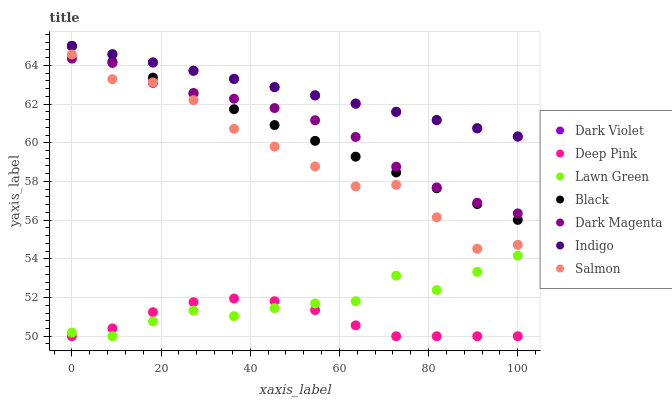Does Deep Pink have the minimum area under the curve?
Answer yes or no. Yes. Does Indigo have the maximum area under the curve?
Answer yes or no. Yes. Does Indigo have the minimum area under the curve?
Answer yes or no. No. Does Deep Pink have the maximum area under the curve?
Answer yes or no. No. Is Dark Violet the smoothest?
Answer yes or no. Yes. Is Lawn Green the roughest?
Answer yes or no. Yes. Is Deep Pink the smoothest?
Answer yes or no. No. Is Deep Pink the roughest?
Answer yes or no. No. Does Lawn Green have the lowest value?
Answer yes or no. Yes. Does Indigo have the lowest value?
Answer yes or no. No. Does Black have the highest value?
Answer yes or no. Yes. Does Deep Pink have the highest value?
Answer yes or no. No. Is Salmon less than Indigo?
Answer yes or no. Yes. Is Dark Violet greater than Lawn Green?
Answer yes or no. Yes. Does Black intersect Dark Violet?
Answer yes or no. Yes. Is Black less than Dark Violet?
Answer yes or no. No. Is Black greater than Dark Violet?
Answer yes or no. No. Does Salmon intersect Indigo?
Answer yes or no. No. 